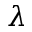Convert formula to latex. <formula><loc_0><loc_0><loc_500><loc_500>\lambda</formula> 